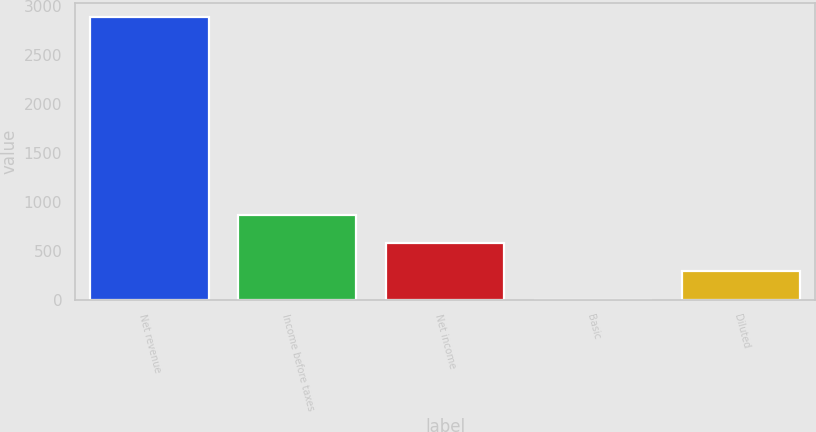<chart> <loc_0><loc_0><loc_500><loc_500><bar_chart><fcel>Net revenue<fcel>Income before taxes<fcel>Net income<fcel>Basic<fcel>Diluted<nl><fcel>2888<fcel>868.33<fcel>579.8<fcel>2.74<fcel>291.27<nl></chart> 